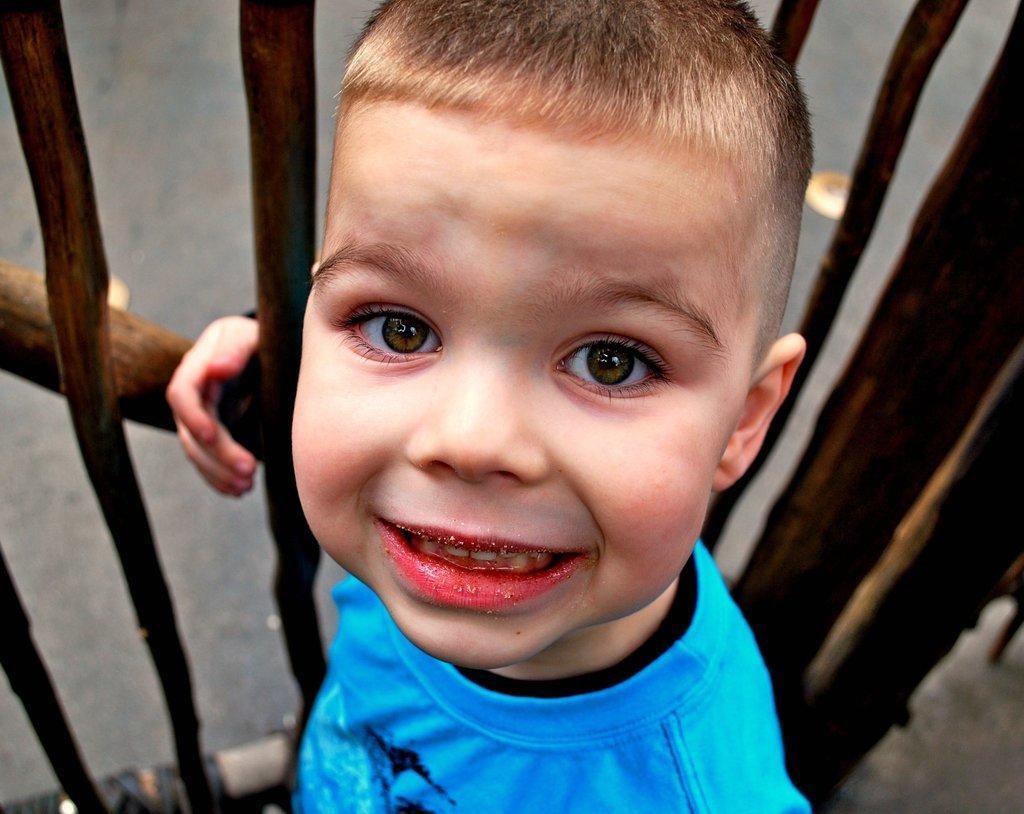In one or two sentences, can you explain what this image depicts? In this image I can see a boy wearing black and blue colored t shirt is smiling. I can see the wooden railing and the ground behind him. 